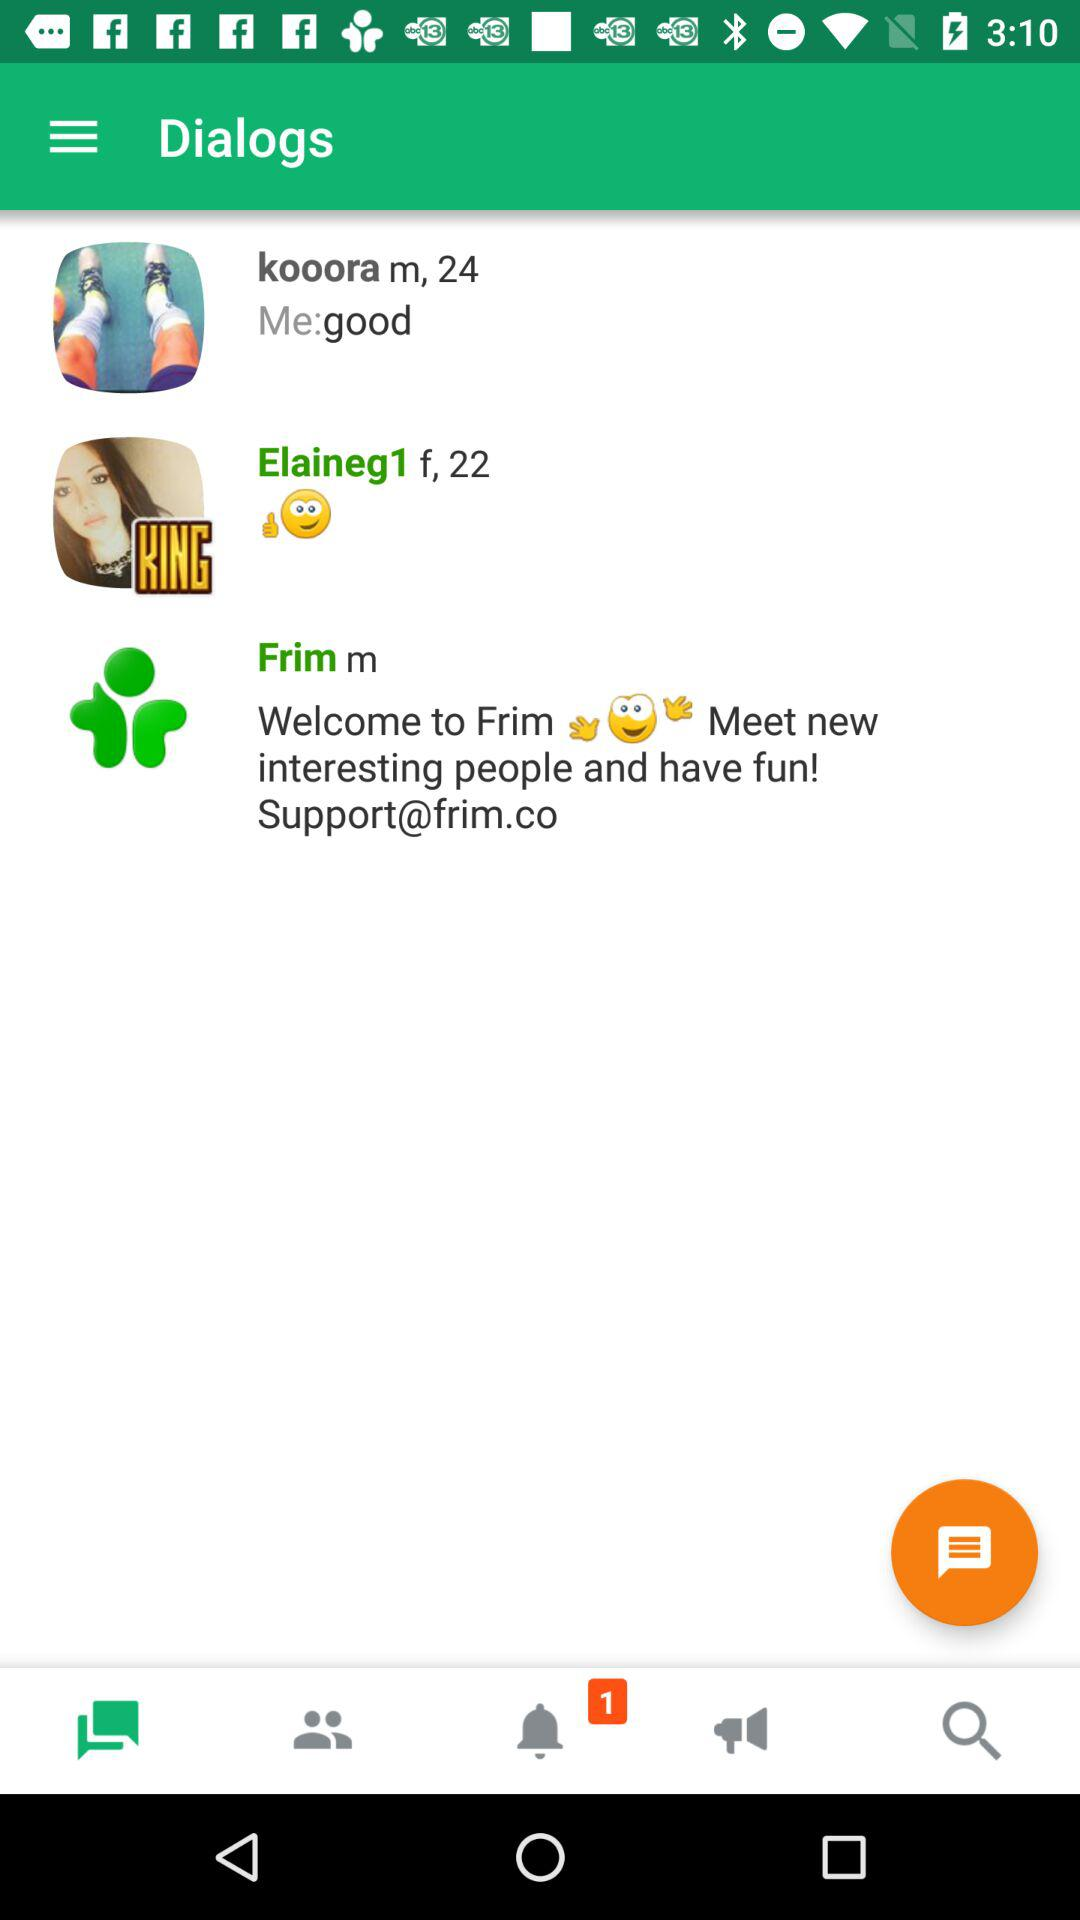How many unread notifications are there? There is 1 unread notification. 